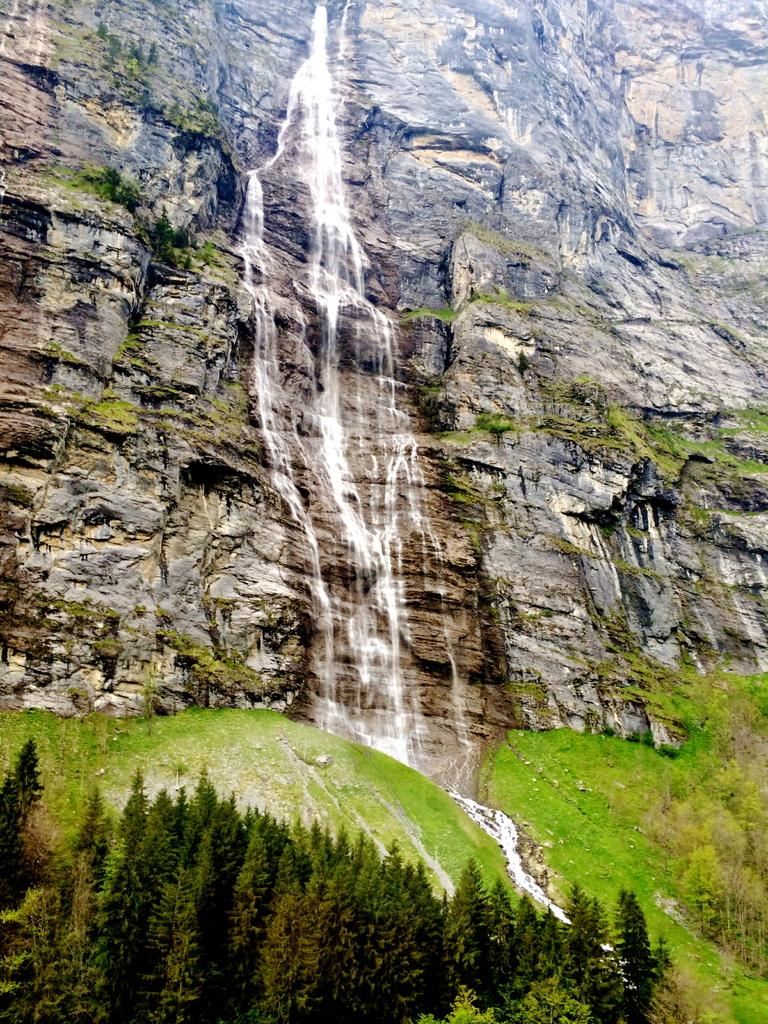What natural feature is the main subject of the image? There is a waterfall in the image. What other geographical features can be seen in the image? The image contains a mountain. What type of vegetation is present in the image? There are trees and grass in the image. How many dogs are sitting on the chair in the image? There are no dogs or chairs present in the image. 